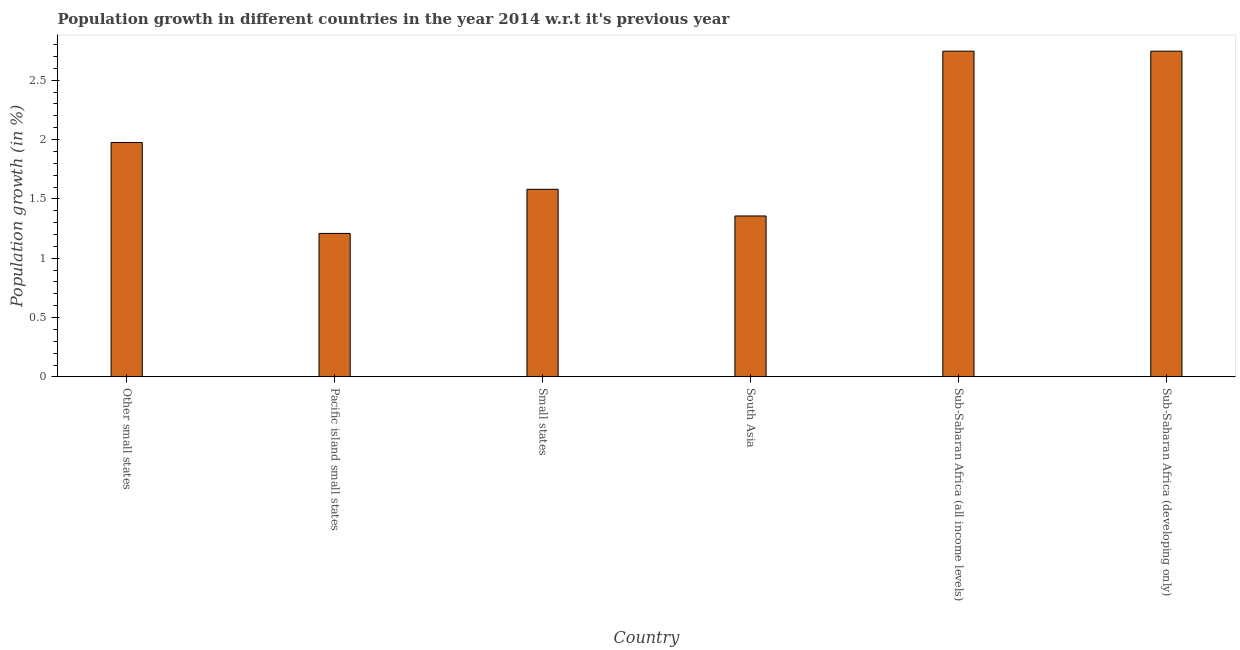Does the graph contain any zero values?
Provide a succinct answer. No. Does the graph contain grids?
Make the answer very short. No. What is the title of the graph?
Give a very brief answer. Population growth in different countries in the year 2014 w.r.t it's previous year. What is the label or title of the X-axis?
Your answer should be very brief. Country. What is the label or title of the Y-axis?
Your answer should be compact. Population growth (in %). What is the population growth in Small states?
Provide a succinct answer. 1.58. Across all countries, what is the maximum population growth?
Offer a very short reply. 2.74. Across all countries, what is the minimum population growth?
Your answer should be compact. 1.21. In which country was the population growth maximum?
Ensure brevity in your answer.  Sub-Saharan Africa (all income levels). In which country was the population growth minimum?
Provide a succinct answer. Pacific island small states. What is the sum of the population growth?
Offer a very short reply. 11.61. What is the difference between the population growth in Other small states and South Asia?
Your answer should be very brief. 0.62. What is the average population growth per country?
Your answer should be very brief. 1.94. What is the median population growth?
Make the answer very short. 1.78. In how many countries, is the population growth greater than 1 %?
Keep it short and to the point. 6. What is the ratio of the population growth in Small states to that in South Asia?
Provide a short and direct response. 1.17. Is the population growth in South Asia less than that in Sub-Saharan Africa (developing only)?
Offer a terse response. Yes. Is the difference between the population growth in Other small states and Pacific island small states greater than the difference between any two countries?
Make the answer very short. No. Is the sum of the population growth in Small states and South Asia greater than the maximum population growth across all countries?
Your response must be concise. Yes. What is the difference between the highest and the lowest population growth?
Provide a short and direct response. 1.54. Are the values on the major ticks of Y-axis written in scientific E-notation?
Your answer should be compact. No. What is the Population growth (in %) in Other small states?
Ensure brevity in your answer.  1.98. What is the Population growth (in %) in Pacific island small states?
Make the answer very short. 1.21. What is the Population growth (in %) in Small states?
Offer a terse response. 1.58. What is the Population growth (in %) of South Asia?
Provide a short and direct response. 1.36. What is the Population growth (in %) in Sub-Saharan Africa (all income levels)?
Your response must be concise. 2.74. What is the Population growth (in %) of Sub-Saharan Africa (developing only)?
Give a very brief answer. 2.74. What is the difference between the Population growth (in %) in Other small states and Pacific island small states?
Make the answer very short. 0.77. What is the difference between the Population growth (in %) in Other small states and Small states?
Offer a very short reply. 0.39. What is the difference between the Population growth (in %) in Other small states and South Asia?
Your response must be concise. 0.62. What is the difference between the Population growth (in %) in Other small states and Sub-Saharan Africa (all income levels)?
Offer a very short reply. -0.77. What is the difference between the Population growth (in %) in Other small states and Sub-Saharan Africa (developing only)?
Offer a very short reply. -0.77. What is the difference between the Population growth (in %) in Pacific island small states and Small states?
Your answer should be very brief. -0.37. What is the difference between the Population growth (in %) in Pacific island small states and South Asia?
Provide a succinct answer. -0.15. What is the difference between the Population growth (in %) in Pacific island small states and Sub-Saharan Africa (all income levels)?
Give a very brief answer. -1.54. What is the difference between the Population growth (in %) in Pacific island small states and Sub-Saharan Africa (developing only)?
Provide a succinct answer. -1.54. What is the difference between the Population growth (in %) in Small states and South Asia?
Offer a very short reply. 0.22. What is the difference between the Population growth (in %) in Small states and Sub-Saharan Africa (all income levels)?
Offer a terse response. -1.16. What is the difference between the Population growth (in %) in Small states and Sub-Saharan Africa (developing only)?
Give a very brief answer. -1.16. What is the difference between the Population growth (in %) in South Asia and Sub-Saharan Africa (all income levels)?
Offer a terse response. -1.39. What is the difference between the Population growth (in %) in South Asia and Sub-Saharan Africa (developing only)?
Your response must be concise. -1.39. What is the difference between the Population growth (in %) in Sub-Saharan Africa (all income levels) and Sub-Saharan Africa (developing only)?
Give a very brief answer. 0. What is the ratio of the Population growth (in %) in Other small states to that in Pacific island small states?
Give a very brief answer. 1.63. What is the ratio of the Population growth (in %) in Other small states to that in Small states?
Your answer should be compact. 1.25. What is the ratio of the Population growth (in %) in Other small states to that in South Asia?
Give a very brief answer. 1.46. What is the ratio of the Population growth (in %) in Other small states to that in Sub-Saharan Africa (all income levels)?
Offer a very short reply. 0.72. What is the ratio of the Population growth (in %) in Other small states to that in Sub-Saharan Africa (developing only)?
Provide a succinct answer. 0.72. What is the ratio of the Population growth (in %) in Pacific island small states to that in Small states?
Offer a terse response. 0.77. What is the ratio of the Population growth (in %) in Pacific island small states to that in South Asia?
Your response must be concise. 0.89. What is the ratio of the Population growth (in %) in Pacific island small states to that in Sub-Saharan Africa (all income levels)?
Ensure brevity in your answer.  0.44. What is the ratio of the Population growth (in %) in Pacific island small states to that in Sub-Saharan Africa (developing only)?
Your answer should be very brief. 0.44. What is the ratio of the Population growth (in %) in Small states to that in South Asia?
Your response must be concise. 1.17. What is the ratio of the Population growth (in %) in Small states to that in Sub-Saharan Africa (all income levels)?
Your answer should be compact. 0.58. What is the ratio of the Population growth (in %) in Small states to that in Sub-Saharan Africa (developing only)?
Keep it short and to the point. 0.58. What is the ratio of the Population growth (in %) in South Asia to that in Sub-Saharan Africa (all income levels)?
Provide a succinct answer. 0.49. What is the ratio of the Population growth (in %) in South Asia to that in Sub-Saharan Africa (developing only)?
Provide a succinct answer. 0.49. What is the ratio of the Population growth (in %) in Sub-Saharan Africa (all income levels) to that in Sub-Saharan Africa (developing only)?
Provide a succinct answer. 1. 